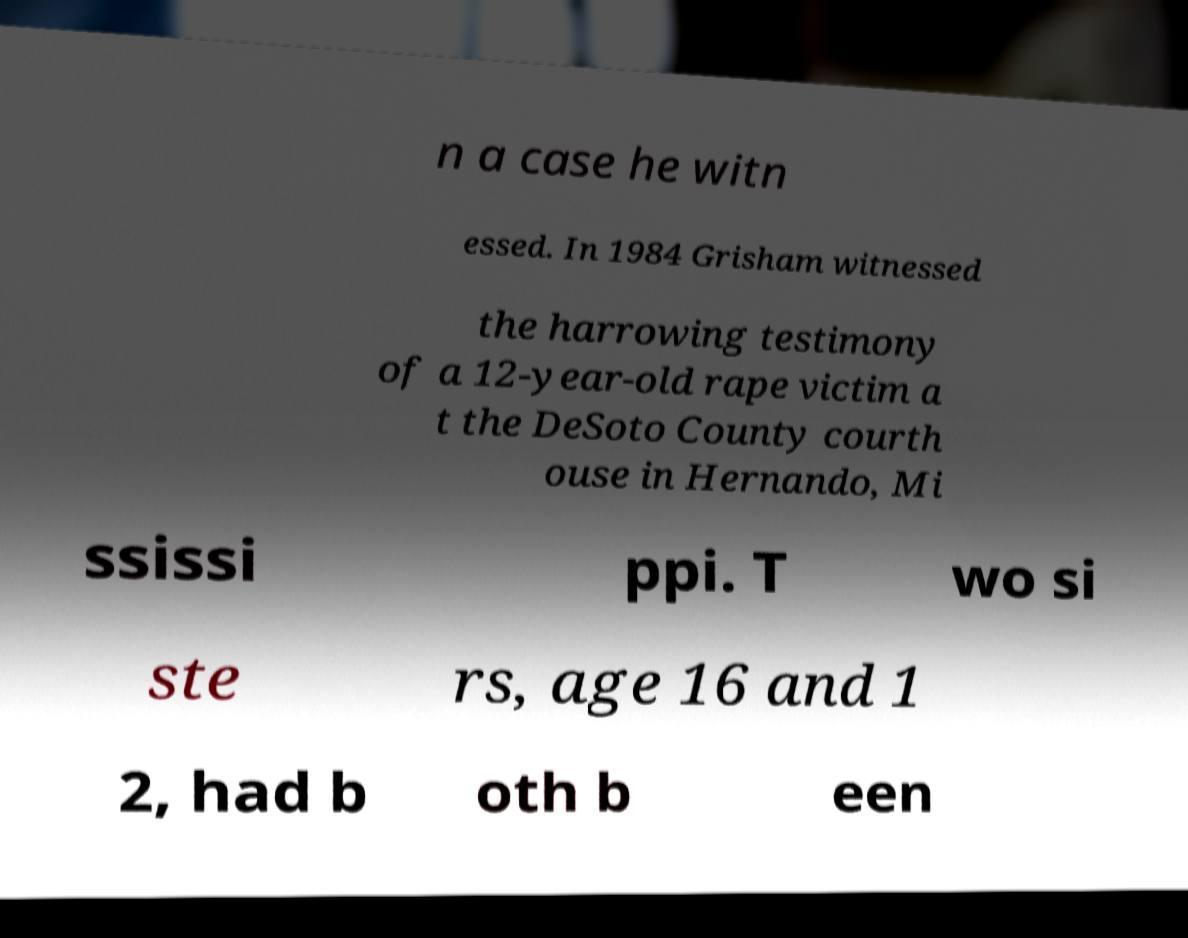I need the written content from this picture converted into text. Can you do that? n a case he witn essed. In 1984 Grisham witnessed the harrowing testimony of a 12-year-old rape victim a t the DeSoto County courth ouse in Hernando, Mi ssissi ppi. T wo si ste rs, age 16 and 1 2, had b oth b een 